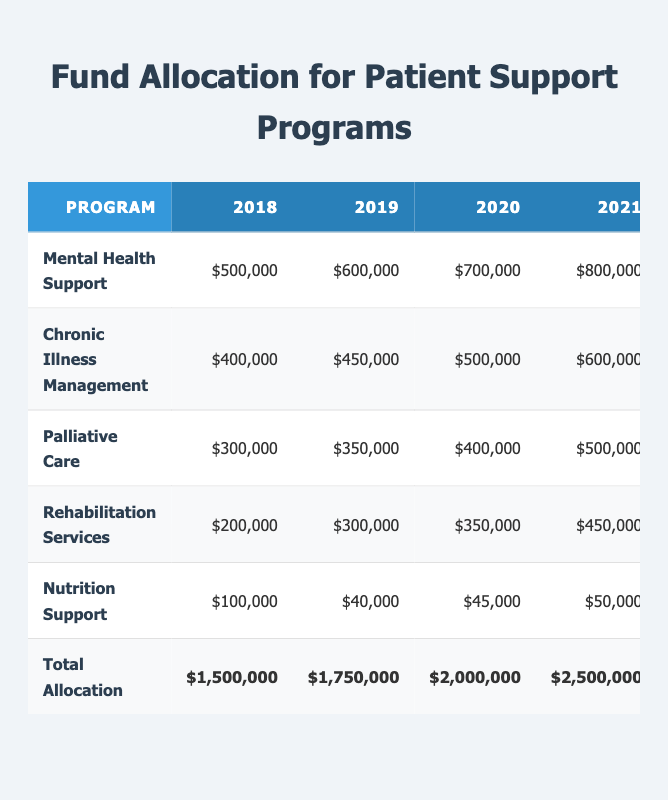What was the total allocation for patient support programs in 2020? The table shows that the total allocation for patient support programs in 2020 is listed under the "Total Allocation" row for that year, which is $2,000,000.
Answer: $2,000,000 Which program received the highest allocation in 2021? By examining the allocations for each program in 2021, Mental Health Support has the highest amount at $800,000.
Answer: Mental Health Support How much more was allocated to Chronic Illness Management in 2022 compared to 2019? The allocation for Chronic Illness Management in 2022 is $750,000 and in 2019 it is $450,000. The difference is calculated as $750,000 - $450,000 = $300,000.
Answer: $300,000 Is the allocation for Nutrition Support in 2023 greater than $50,000? The table indicates that the allocation for Nutrition Support in 2023 is $60,000, which is indeed greater than $50,000.
Answer: Yes What is the average allocation for Palliative Care over the years 2018 to 2023? To calculate the average, sum the annual allocations for Palliative Care: ($300,000 + $350,000 + $400,000 + $500,000 + $600,000 + $650,000) = $2,800,000. Then divide by the number of years (6): $2,800,000 / 6 = $466,666.67 (approximately).
Answer: $466,666.67 